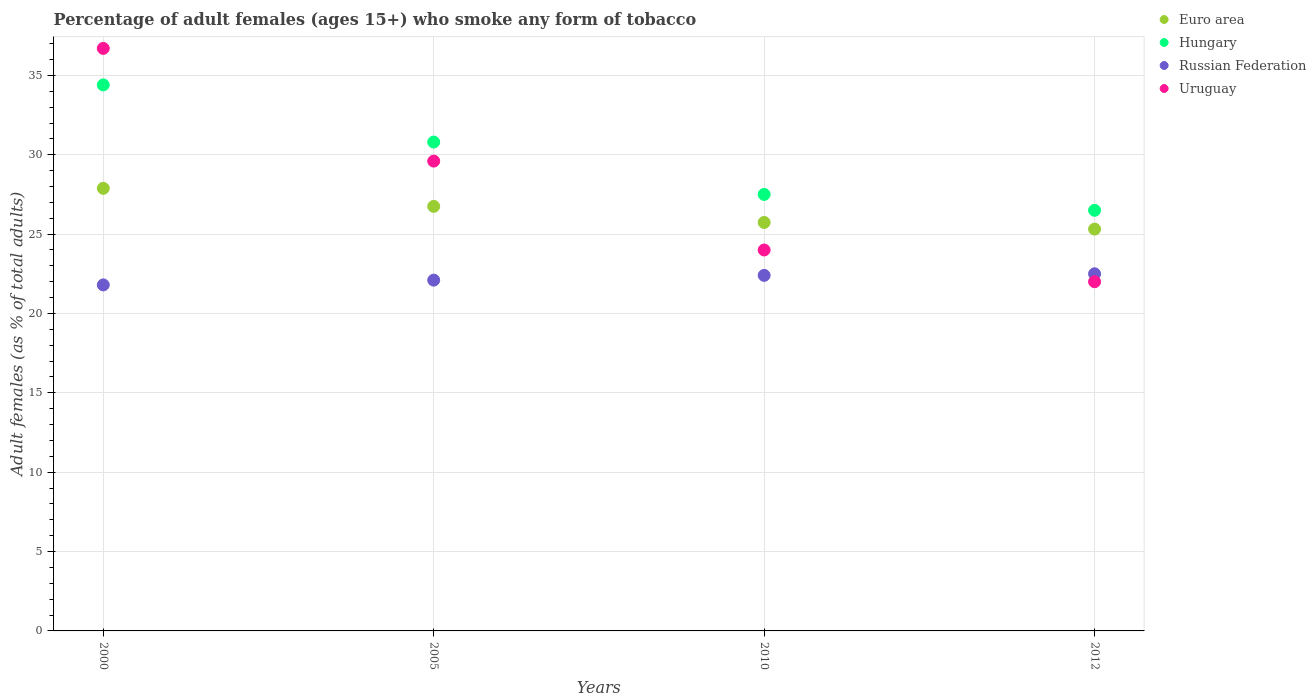What is the percentage of adult females who smoke in Euro area in 2005?
Your response must be concise. 26.75. Across all years, what is the maximum percentage of adult females who smoke in Euro area?
Ensure brevity in your answer.  27.88. Across all years, what is the minimum percentage of adult females who smoke in Uruguay?
Provide a succinct answer. 22. What is the total percentage of adult females who smoke in Uruguay in the graph?
Keep it short and to the point. 112.3. What is the difference between the percentage of adult females who smoke in Russian Federation in 2010 and that in 2012?
Offer a terse response. -0.1. What is the difference between the percentage of adult females who smoke in Euro area in 2000 and the percentage of adult females who smoke in Russian Federation in 2012?
Make the answer very short. 5.38. What is the average percentage of adult females who smoke in Hungary per year?
Offer a terse response. 29.8. In the year 2010, what is the difference between the percentage of adult females who smoke in Russian Federation and percentage of adult females who smoke in Euro area?
Ensure brevity in your answer.  -3.33. What is the ratio of the percentage of adult females who smoke in Euro area in 2005 to that in 2012?
Keep it short and to the point. 1.06. Is the percentage of adult females who smoke in Euro area in 2005 less than that in 2010?
Provide a short and direct response. No. What is the difference between the highest and the second highest percentage of adult females who smoke in Uruguay?
Ensure brevity in your answer.  7.1. What is the difference between the highest and the lowest percentage of adult females who smoke in Hungary?
Your response must be concise. 7.9. Is the sum of the percentage of adult females who smoke in Uruguay in 2000 and 2012 greater than the maximum percentage of adult females who smoke in Hungary across all years?
Offer a terse response. Yes. Is it the case that in every year, the sum of the percentage of adult females who smoke in Russian Federation and percentage of adult females who smoke in Hungary  is greater than the percentage of adult females who smoke in Euro area?
Ensure brevity in your answer.  Yes. Is the percentage of adult females who smoke in Hungary strictly greater than the percentage of adult females who smoke in Euro area over the years?
Offer a terse response. Yes. Is the percentage of adult females who smoke in Uruguay strictly less than the percentage of adult females who smoke in Russian Federation over the years?
Your response must be concise. No. What is the difference between two consecutive major ticks on the Y-axis?
Provide a short and direct response. 5. Are the values on the major ticks of Y-axis written in scientific E-notation?
Ensure brevity in your answer.  No. Where does the legend appear in the graph?
Keep it short and to the point. Top right. What is the title of the graph?
Keep it short and to the point. Percentage of adult females (ages 15+) who smoke any form of tobacco. What is the label or title of the X-axis?
Your answer should be compact. Years. What is the label or title of the Y-axis?
Your response must be concise. Adult females (as % of total adults). What is the Adult females (as % of total adults) of Euro area in 2000?
Your answer should be very brief. 27.88. What is the Adult females (as % of total adults) of Hungary in 2000?
Provide a short and direct response. 34.4. What is the Adult females (as % of total adults) in Russian Federation in 2000?
Provide a succinct answer. 21.8. What is the Adult females (as % of total adults) in Uruguay in 2000?
Ensure brevity in your answer.  36.7. What is the Adult females (as % of total adults) of Euro area in 2005?
Make the answer very short. 26.75. What is the Adult females (as % of total adults) in Hungary in 2005?
Your answer should be compact. 30.8. What is the Adult females (as % of total adults) of Russian Federation in 2005?
Ensure brevity in your answer.  22.1. What is the Adult females (as % of total adults) of Uruguay in 2005?
Offer a very short reply. 29.6. What is the Adult females (as % of total adults) of Euro area in 2010?
Your answer should be very brief. 25.73. What is the Adult females (as % of total adults) of Russian Federation in 2010?
Offer a terse response. 22.4. What is the Adult females (as % of total adults) in Uruguay in 2010?
Make the answer very short. 24. What is the Adult females (as % of total adults) of Euro area in 2012?
Offer a terse response. 25.32. What is the Adult females (as % of total adults) in Uruguay in 2012?
Your answer should be very brief. 22. Across all years, what is the maximum Adult females (as % of total adults) of Euro area?
Your answer should be compact. 27.88. Across all years, what is the maximum Adult females (as % of total adults) of Hungary?
Offer a very short reply. 34.4. Across all years, what is the maximum Adult females (as % of total adults) in Russian Federation?
Provide a succinct answer. 22.5. Across all years, what is the maximum Adult females (as % of total adults) in Uruguay?
Provide a succinct answer. 36.7. Across all years, what is the minimum Adult females (as % of total adults) in Euro area?
Offer a very short reply. 25.32. Across all years, what is the minimum Adult females (as % of total adults) in Hungary?
Give a very brief answer. 26.5. Across all years, what is the minimum Adult females (as % of total adults) in Russian Federation?
Provide a short and direct response. 21.8. What is the total Adult females (as % of total adults) of Euro area in the graph?
Ensure brevity in your answer.  105.68. What is the total Adult females (as % of total adults) in Hungary in the graph?
Offer a very short reply. 119.2. What is the total Adult females (as % of total adults) in Russian Federation in the graph?
Keep it short and to the point. 88.8. What is the total Adult females (as % of total adults) of Uruguay in the graph?
Give a very brief answer. 112.3. What is the difference between the Adult females (as % of total adults) in Euro area in 2000 and that in 2005?
Ensure brevity in your answer.  1.14. What is the difference between the Adult females (as % of total adults) of Hungary in 2000 and that in 2005?
Provide a succinct answer. 3.6. What is the difference between the Adult females (as % of total adults) in Russian Federation in 2000 and that in 2005?
Give a very brief answer. -0.3. What is the difference between the Adult females (as % of total adults) of Euro area in 2000 and that in 2010?
Provide a short and direct response. 2.15. What is the difference between the Adult females (as % of total adults) in Uruguay in 2000 and that in 2010?
Make the answer very short. 12.7. What is the difference between the Adult females (as % of total adults) in Euro area in 2000 and that in 2012?
Offer a terse response. 2.57. What is the difference between the Adult females (as % of total adults) in Uruguay in 2000 and that in 2012?
Your answer should be compact. 14.7. What is the difference between the Adult females (as % of total adults) in Euro area in 2005 and that in 2010?
Provide a short and direct response. 1.01. What is the difference between the Adult females (as % of total adults) in Russian Federation in 2005 and that in 2010?
Your answer should be compact. -0.3. What is the difference between the Adult females (as % of total adults) in Euro area in 2005 and that in 2012?
Your answer should be compact. 1.43. What is the difference between the Adult females (as % of total adults) of Hungary in 2005 and that in 2012?
Offer a very short reply. 4.3. What is the difference between the Adult females (as % of total adults) in Russian Federation in 2005 and that in 2012?
Make the answer very short. -0.4. What is the difference between the Adult females (as % of total adults) in Uruguay in 2005 and that in 2012?
Provide a succinct answer. 7.6. What is the difference between the Adult females (as % of total adults) in Euro area in 2010 and that in 2012?
Offer a terse response. 0.42. What is the difference between the Adult females (as % of total adults) in Hungary in 2010 and that in 2012?
Offer a very short reply. 1. What is the difference between the Adult females (as % of total adults) in Uruguay in 2010 and that in 2012?
Give a very brief answer. 2. What is the difference between the Adult females (as % of total adults) in Euro area in 2000 and the Adult females (as % of total adults) in Hungary in 2005?
Your answer should be very brief. -2.92. What is the difference between the Adult females (as % of total adults) in Euro area in 2000 and the Adult females (as % of total adults) in Russian Federation in 2005?
Your answer should be very brief. 5.78. What is the difference between the Adult females (as % of total adults) in Euro area in 2000 and the Adult females (as % of total adults) in Uruguay in 2005?
Keep it short and to the point. -1.72. What is the difference between the Adult females (as % of total adults) of Russian Federation in 2000 and the Adult females (as % of total adults) of Uruguay in 2005?
Offer a terse response. -7.8. What is the difference between the Adult females (as % of total adults) in Euro area in 2000 and the Adult females (as % of total adults) in Hungary in 2010?
Offer a very short reply. 0.38. What is the difference between the Adult females (as % of total adults) in Euro area in 2000 and the Adult females (as % of total adults) in Russian Federation in 2010?
Offer a terse response. 5.48. What is the difference between the Adult females (as % of total adults) of Euro area in 2000 and the Adult females (as % of total adults) of Uruguay in 2010?
Your answer should be very brief. 3.88. What is the difference between the Adult females (as % of total adults) of Hungary in 2000 and the Adult females (as % of total adults) of Russian Federation in 2010?
Give a very brief answer. 12. What is the difference between the Adult females (as % of total adults) in Hungary in 2000 and the Adult females (as % of total adults) in Uruguay in 2010?
Your answer should be compact. 10.4. What is the difference between the Adult females (as % of total adults) in Russian Federation in 2000 and the Adult females (as % of total adults) in Uruguay in 2010?
Your response must be concise. -2.2. What is the difference between the Adult females (as % of total adults) of Euro area in 2000 and the Adult females (as % of total adults) of Hungary in 2012?
Keep it short and to the point. 1.38. What is the difference between the Adult females (as % of total adults) of Euro area in 2000 and the Adult females (as % of total adults) of Russian Federation in 2012?
Provide a short and direct response. 5.38. What is the difference between the Adult females (as % of total adults) of Euro area in 2000 and the Adult females (as % of total adults) of Uruguay in 2012?
Make the answer very short. 5.88. What is the difference between the Adult females (as % of total adults) in Hungary in 2000 and the Adult females (as % of total adults) in Russian Federation in 2012?
Offer a very short reply. 11.9. What is the difference between the Adult females (as % of total adults) in Hungary in 2000 and the Adult females (as % of total adults) in Uruguay in 2012?
Your response must be concise. 12.4. What is the difference between the Adult females (as % of total adults) of Euro area in 2005 and the Adult females (as % of total adults) of Hungary in 2010?
Provide a succinct answer. -0.75. What is the difference between the Adult females (as % of total adults) in Euro area in 2005 and the Adult females (as % of total adults) in Russian Federation in 2010?
Ensure brevity in your answer.  4.35. What is the difference between the Adult females (as % of total adults) in Euro area in 2005 and the Adult females (as % of total adults) in Uruguay in 2010?
Give a very brief answer. 2.75. What is the difference between the Adult females (as % of total adults) of Hungary in 2005 and the Adult females (as % of total adults) of Russian Federation in 2010?
Give a very brief answer. 8.4. What is the difference between the Adult females (as % of total adults) in Hungary in 2005 and the Adult females (as % of total adults) in Uruguay in 2010?
Your answer should be compact. 6.8. What is the difference between the Adult females (as % of total adults) in Euro area in 2005 and the Adult females (as % of total adults) in Hungary in 2012?
Offer a very short reply. 0.25. What is the difference between the Adult females (as % of total adults) in Euro area in 2005 and the Adult females (as % of total adults) in Russian Federation in 2012?
Your answer should be very brief. 4.25. What is the difference between the Adult females (as % of total adults) in Euro area in 2005 and the Adult females (as % of total adults) in Uruguay in 2012?
Make the answer very short. 4.75. What is the difference between the Adult females (as % of total adults) in Hungary in 2005 and the Adult females (as % of total adults) in Uruguay in 2012?
Keep it short and to the point. 8.8. What is the difference between the Adult females (as % of total adults) of Euro area in 2010 and the Adult females (as % of total adults) of Hungary in 2012?
Your answer should be compact. -0.77. What is the difference between the Adult females (as % of total adults) in Euro area in 2010 and the Adult females (as % of total adults) in Russian Federation in 2012?
Provide a short and direct response. 3.23. What is the difference between the Adult females (as % of total adults) of Euro area in 2010 and the Adult females (as % of total adults) of Uruguay in 2012?
Give a very brief answer. 3.73. What is the average Adult females (as % of total adults) of Euro area per year?
Ensure brevity in your answer.  26.42. What is the average Adult females (as % of total adults) of Hungary per year?
Ensure brevity in your answer.  29.8. What is the average Adult females (as % of total adults) of Uruguay per year?
Make the answer very short. 28.07. In the year 2000, what is the difference between the Adult females (as % of total adults) of Euro area and Adult females (as % of total adults) of Hungary?
Make the answer very short. -6.52. In the year 2000, what is the difference between the Adult females (as % of total adults) of Euro area and Adult females (as % of total adults) of Russian Federation?
Ensure brevity in your answer.  6.08. In the year 2000, what is the difference between the Adult females (as % of total adults) in Euro area and Adult females (as % of total adults) in Uruguay?
Your answer should be very brief. -8.82. In the year 2000, what is the difference between the Adult females (as % of total adults) of Hungary and Adult females (as % of total adults) of Russian Federation?
Provide a short and direct response. 12.6. In the year 2000, what is the difference between the Adult females (as % of total adults) in Russian Federation and Adult females (as % of total adults) in Uruguay?
Your answer should be compact. -14.9. In the year 2005, what is the difference between the Adult females (as % of total adults) of Euro area and Adult females (as % of total adults) of Hungary?
Provide a short and direct response. -4.05. In the year 2005, what is the difference between the Adult females (as % of total adults) in Euro area and Adult females (as % of total adults) in Russian Federation?
Ensure brevity in your answer.  4.65. In the year 2005, what is the difference between the Adult females (as % of total adults) in Euro area and Adult females (as % of total adults) in Uruguay?
Your response must be concise. -2.85. In the year 2005, what is the difference between the Adult females (as % of total adults) in Hungary and Adult females (as % of total adults) in Uruguay?
Your response must be concise. 1.2. In the year 2005, what is the difference between the Adult females (as % of total adults) in Russian Federation and Adult females (as % of total adults) in Uruguay?
Make the answer very short. -7.5. In the year 2010, what is the difference between the Adult females (as % of total adults) of Euro area and Adult females (as % of total adults) of Hungary?
Keep it short and to the point. -1.77. In the year 2010, what is the difference between the Adult females (as % of total adults) of Euro area and Adult females (as % of total adults) of Russian Federation?
Make the answer very short. 3.33. In the year 2010, what is the difference between the Adult females (as % of total adults) in Euro area and Adult females (as % of total adults) in Uruguay?
Your answer should be compact. 1.73. In the year 2010, what is the difference between the Adult females (as % of total adults) of Hungary and Adult females (as % of total adults) of Russian Federation?
Keep it short and to the point. 5.1. In the year 2010, what is the difference between the Adult females (as % of total adults) in Russian Federation and Adult females (as % of total adults) in Uruguay?
Ensure brevity in your answer.  -1.6. In the year 2012, what is the difference between the Adult females (as % of total adults) in Euro area and Adult females (as % of total adults) in Hungary?
Make the answer very short. -1.18. In the year 2012, what is the difference between the Adult females (as % of total adults) of Euro area and Adult females (as % of total adults) of Russian Federation?
Provide a succinct answer. 2.82. In the year 2012, what is the difference between the Adult females (as % of total adults) of Euro area and Adult females (as % of total adults) of Uruguay?
Your answer should be compact. 3.32. In the year 2012, what is the difference between the Adult females (as % of total adults) in Hungary and Adult females (as % of total adults) in Russian Federation?
Make the answer very short. 4. In the year 2012, what is the difference between the Adult females (as % of total adults) in Russian Federation and Adult females (as % of total adults) in Uruguay?
Keep it short and to the point. 0.5. What is the ratio of the Adult females (as % of total adults) of Euro area in 2000 to that in 2005?
Ensure brevity in your answer.  1.04. What is the ratio of the Adult females (as % of total adults) of Hungary in 2000 to that in 2005?
Ensure brevity in your answer.  1.12. What is the ratio of the Adult females (as % of total adults) in Russian Federation in 2000 to that in 2005?
Your answer should be compact. 0.99. What is the ratio of the Adult females (as % of total adults) of Uruguay in 2000 to that in 2005?
Ensure brevity in your answer.  1.24. What is the ratio of the Adult females (as % of total adults) in Euro area in 2000 to that in 2010?
Your response must be concise. 1.08. What is the ratio of the Adult females (as % of total adults) of Hungary in 2000 to that in 2010?
Your response must be concise. 1.25. What is the ratio of the Adult females (as % of total adults) of Russian Federation in 2000 to that in 2010?
Ensure brevity in your answer.  0.97. What is the ratio of the Adult females (as % of total adults) of Uruguay in 2000 to that in 2010?
Your answer should be very brief. 1.53. What is the ratio of the Adult females (as % of total adults) in Euro area in 2000 to that in 2012?
Offer a very short reply. 1.1. What is the ratio of the Adult females (as % of total adults) in Hungary in 2000 to that in 2012?
Your answer should be very brief. 1.3. What is the ratio of the Adult females (as % of total adults) of Russian Federation in 2000 to that in 2012?
Offer a terse response. 0.97. What is the ratio of the Adult females (as % of total adults) of Uruguay in 2000 to that in 2012?
Offer a very short reply. 1.67. What is the ratio of the Adult females (as % of total adults) in Euro area in 2005 to that in 2010?
Your answer should be compact. 1.04. What is the ratio of the Adult females (as % of total adults) of Hungary in 2005 to that in 2010?
Make the answer very short. 1.12. What is the ratio of the Adult females (as % of total adults) of Russian Federation in 2005 to that in 2010?
Make the answer very short. 0.99. What is the ratio of the Adult females (as % of total adults) of Uruguay in 2005 to that in 2010?
Make the answer very short. 1.23. What is the ratio of the Adult females (as % of total adults) of Euro area in 2005 to that in 2012?
Your answer should be very brief. 1.06. What is the ratio of the Adult females (as % of total adults) in Hungary in 2005 to that in 2012?
Provide a short and direct response. 1.16. What is the ratio of the Adult females (as % of total adults) of Russian Federation in 2005 to that in 2012?
Your answer should be compact. 0.98. What is the ratio of the Adult females (as % of total adults) in Uruguay in 2005 to that in 2012?
Give a very brief answer. 1.35. What is the ratio of the Adult females (as % of total adults) of Euro area in 2010 to that in 2012?
Provide a short and direct response. 1.02. What is the ratio of the Adult females (as % of total adults) of Hungary in 2010 to that in 2012?
Your response must be concise. 1.04. What is the ratio of the Adult females (as % of total adults) in Uruguay in 2010 to that in 2012?
Your answer should be very brief. 1.09. What is the difference between the highest and the second highest Adult females (as % of total adults) in Euro area?
Ensure brevity in your answer.  1.14. What is the difference between the highest and the second highest Adult females (as % of total adults) in Russian Federation?
Your response must be concise. 0.1. What is the difference between the highest and the lowest Adult females (as % of total adults) in Euro area?
Your response must be concise. 2.57. What is the difference between the highest and the lowest Adult females (as % of total adults) in Hungary?
Make the answer very short. 7.9. 